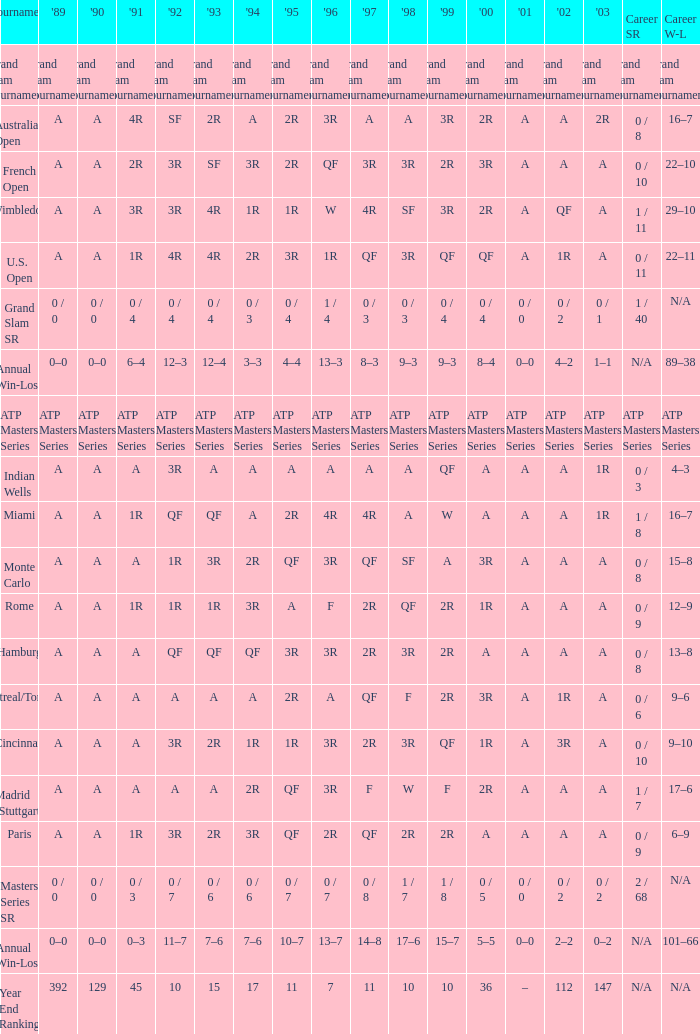What was the value in 1989 with QF in 1997 and A in 1993? A. 